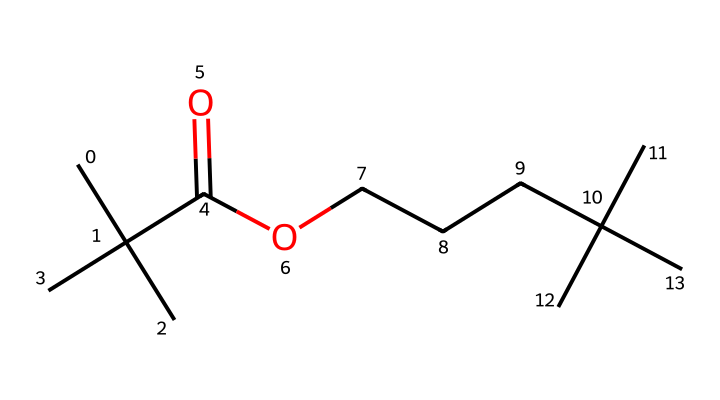What is the total number of carbon atoms in this compound? By analyzing the SMILES string, we count the occurrences of 'C', which indicates carbon atoms. There are a total of 14 carbon atoms present in the structure.
Answer: 14 How many oxygen atoms are present in this molecule? The SMILES representation includes 'O', which denotes oxygen atoms. Counting the 'O's in the structure, there are 2 oxygen atoms present.
Answer: 2 What type of functional group is featured in this compound? The structure includes the component 'C(=O)O', which is indicative of a carboxylic acid group. Therefore, the main functional group is a carboxylic acid.
Answer: carboxylic acid Is this compound likely to be hydrophilic or hydrophobic? The presence of the carboxylic acid functional group suggests that the compound has polar characteristics, making it relatively hydrophilic.
Answer: hydrophilic Does this chemical contain branching structures? The presence of '(C)(C)' and '(C)' in the SMILES indicates branching due to the additional carbon groups connected to the main chain. This confirms the presence of branched structures.
Answer: yes What is the degree of saturation of this compound? The presence of double bonds in the carboxylic acid affects the degree of saturation. Considering both the C atoms and the double bond, the degree of saturation indicates that the compound is unsaturated.
Answer: unsaturated 